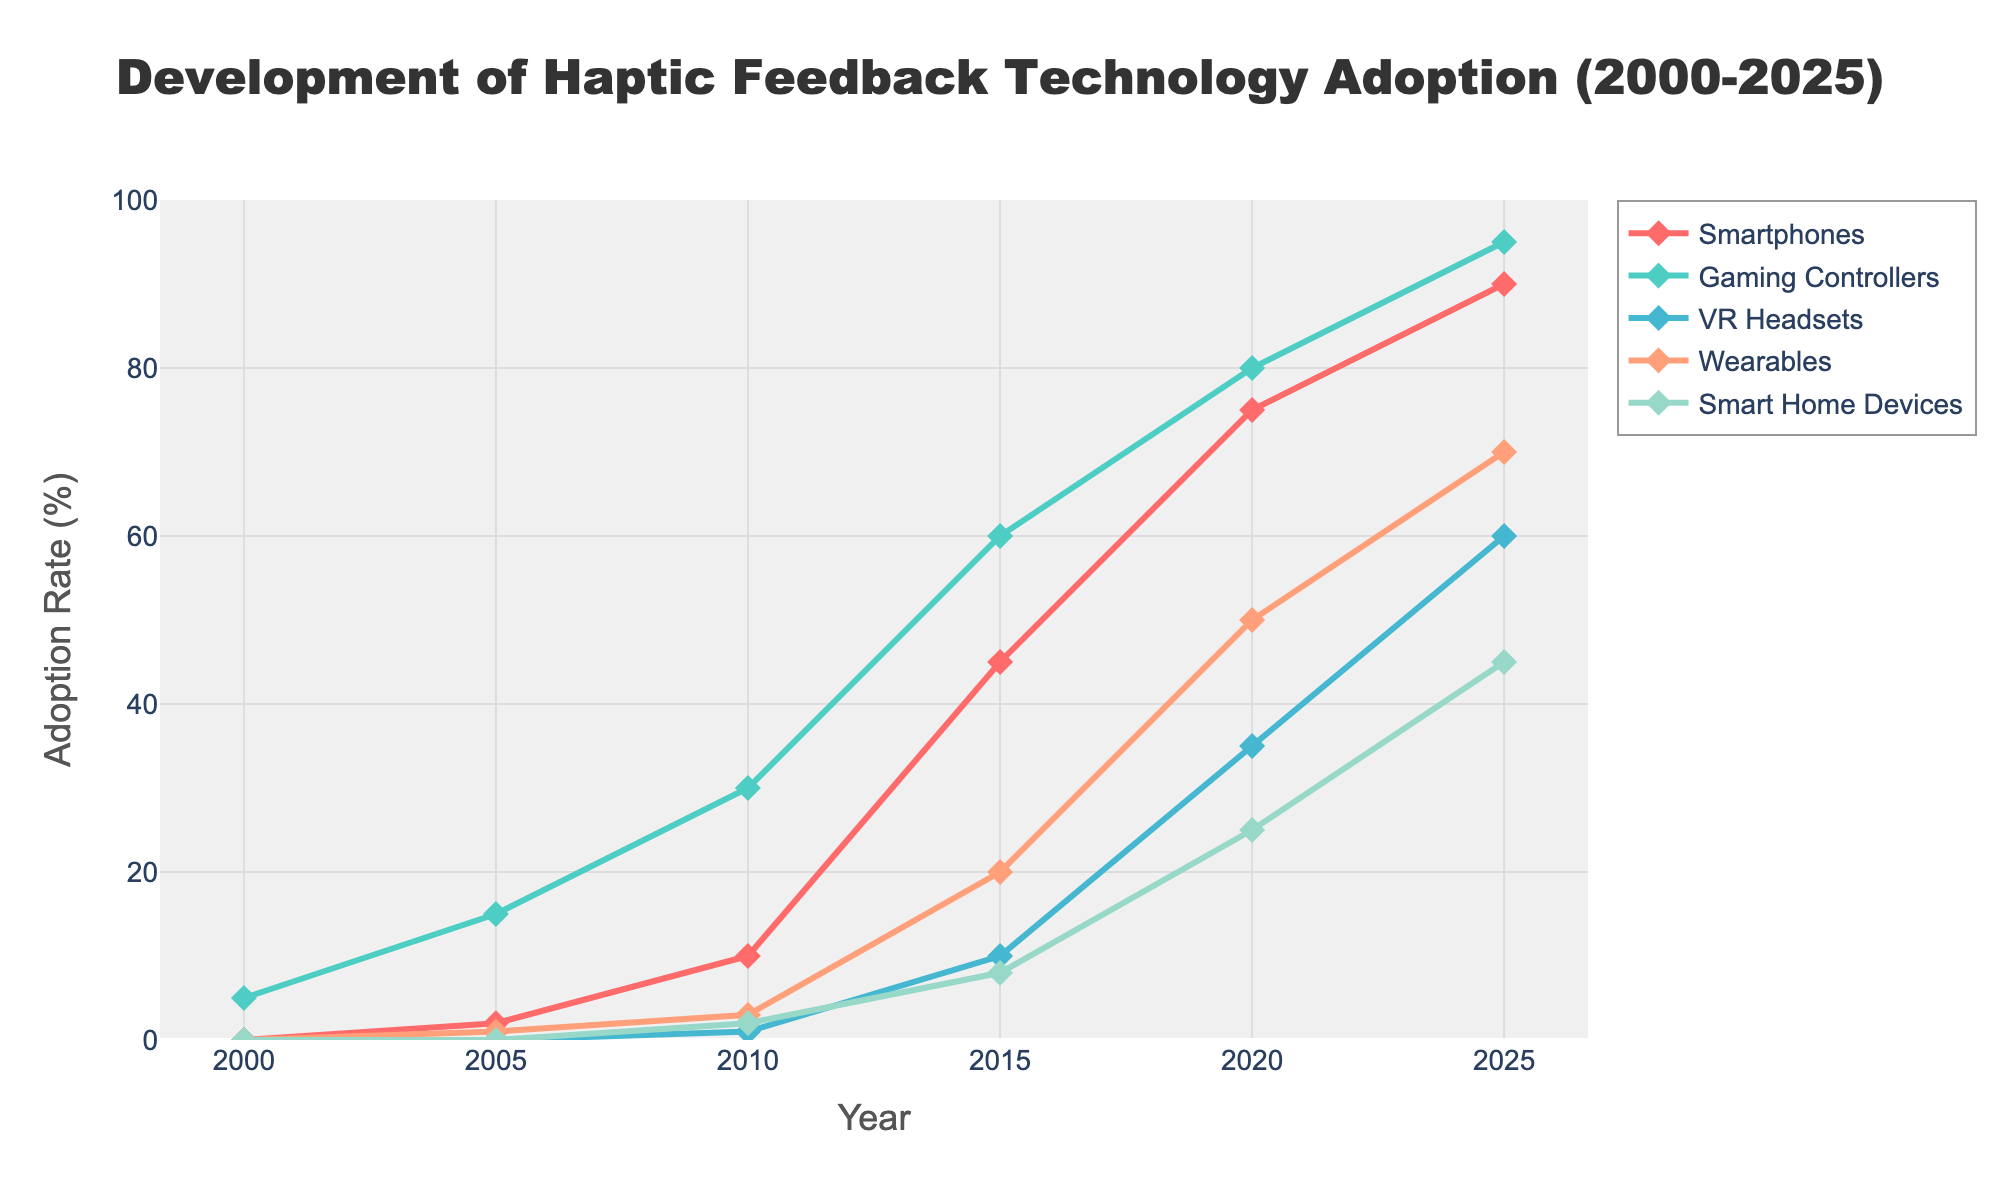Which device categories reached an adoption rate of 60% or higher by 2025? By examining the 2025 data points in the chart, you can see which lines cross or reach the 60% mark. VR Headsets, Gaming Controllers, Smartphones, and Wearables show adoption rates of 60% or higher by 2025.
Answer: VR Headsets, Gaming Controllers, Smartphones, and Wearables In what year did wearables first reach an adoption rate higher than 40%? Look at the line representing Wearables and find the first point where it surpasses the 40% mark. In 2020, the Wearables adoption rate surpassed 40%.
Answer: 2020 Which category had the highest growth in adoption rate from 2000 to 2025? To determine the highest growth, calculate the difference between the adoption rate in 2025 and 2000 for each category. The Gaming Controllers category increased from 5% in 2000 to 95% in 2025, a growth of 90%.
Answer: Gaming Controllers By how much did the adoption rate of VR Headsets increase from 2010 to 2020? Subtract the 2010 adoption rate of VR Headsets from the 2020 adoption rate. The rate increased from 1% in 2010 to 35% in 2020, resulting in an increase of 34%.
Answer: 34% What is the color used to represent the Wearables category in the chart? Identify the line color associated with the Wearables category in the legend. The line for Wearables is light orange.
Answer: Light Orange Compare the growth rates of Smart Home Devices and Smartphones from 2005 to 2025. Which one grew more and by how much? Calculate the growth of each category by subtracting their 2005 adoption rates from the 2025 rates. Smart Home Devices grew from 0% to 45%, a 45% increase. Smartphones grew from 2% to 90%, a 88% increase. Smartphones grew more by 43%.
Answer: Smartphones grew more by 43% In which year did Gaming Controllers reach an adoption rate of 30% or higher? Find the earliest point where the Gaming Controllers line crosses the 30% mark. Gaming Controllers reached an adoption rate of 30% in 2010.
Answer: 2010 What was the average adoption rate of all categories in 2020? Sum the adoption rates of all categories in 2020 and divide by the number of categories. The adoption rates in 2020 were 75% + 80% + 35% + 50% + 25% = 265%. Dividing by 5 categories gives an average of 53%.
Answer: 53% 